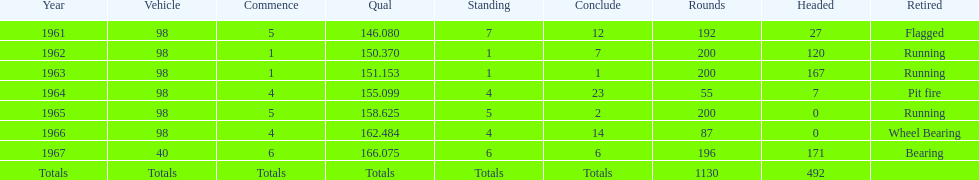How many total laps have been driven in the indy 500? 1130. Parse the table in full. {'header': ['Year', 'Vehicle', 'Commence', 'Qual', 'Standing', 'Conclude', 'Rounds', 'Headed', 'Retired'], 'rows': [['1961', '98', '5', '146.080', '7', '12', '192', '27', 'Flagged'], ['1962', '98', '1', '150.370', '1', '7', '200', '120', 'Running'], ['1963', '98', '1', '151.153', '1', '1', '200', '167', 'Running'], ['1964', '98', '4', '155.099', '4', '23', '55', '7', 'Pit fire'], ['1965', '98', '5', '158.625', '5', '2', '200', '0', 'Running'], ['1966', '98', '4', '162.484', '4', '14', '87', '0', 'Wheel Bearing'], ['1967', '40', '6', '166.075', '6', '6', '196', '171', 'Bearing'], ['Totals', 'Totals', 'Totals', 'Totals', 'Totals', 'Totals', '1130', '492', '']]} 